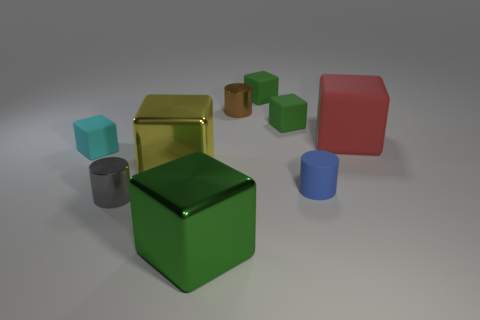Subtract all gray cylinders. How many green cubes are left? 3 Subtract all yellow cubes. How many cubes are left? 5 Subtract all yellow cubes. How many cubes are left? 5 Subtract all blue cubes. Subtract all brown cylinders. How many cubes are left? 6 Add 1 green matte cubes. How many objects exist? 10 Subtract all blocks. How many objects are left? 3 Add 5 small cyan objects. How many small cyan objects exist? 6 Subtract 0 brown cubes. How many objects are left? 9 Subtract all tiny green matte things. Subtract all large green metallic things. How many objects are left? 6 Add 8 red rubber things. How many red rubber things are left? 9 